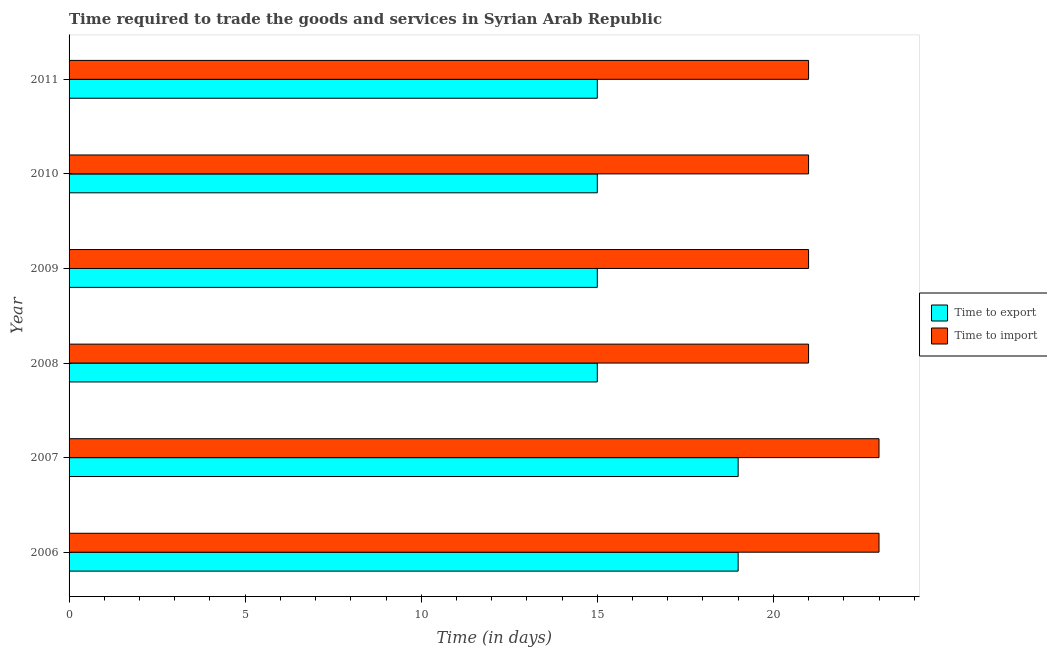How many groups of bars are there?
Make the answer very short. 6. Are the number of bars per tick equal to the number of legend labels?
Keep it short and to the point. Yes. Are the number of bars on each tick of the Y-axis equal?
Provide a succinct answer. Yes. How many bars are there on the 5th tick from the top?
Offer a very short reply. 2. How many bars are there on the 2nd tick from the bottom?
Keep it short and to the point. 2. In how many cases, is the number of bars for a given year not equal to the number of legend labels?
Provide a succinct answer. 0. What is the time to export in 2006?
Your answer should be compact. 19. Across all years, what is the maximum time to export?
Make the answer very short. 19. Across all years, what is the minimum time to export?
Provide a succinct answer. 15. What is the total time to import in the graph?
Offer a terse response. 130. What is the difference between the time to import in 2006 and that in 2010?
Offer a very short reply. 2. What is the difference between the time to export in 2008 and the time to import in 2009?
Your response must be concise. -6. What is the average time to import per year?
Offer a terse response. 21.67. In how many years, is the time to export greater than 6 days?
Provide a short and direct response. 6. Is the time to export in 2006 less than that in 2010?
Ensure brevity in your answer.  No. Is the difference between the time to import in 2006 and 2011 greater than the difference between the time to export in 2006 and 2011?
Give a very brief answer. No. What is the difference between the highest and the lowest time to import?
Keep it short and to the point. 2. Is the sum of the time to export in 2006 and 2010 greater than the maximum time to import across all years?
Provide a short and direct response. Yes. What does the 2nd bar from the top in 2011 represents?
Make the answer very short. Time to export. What does the 2nd bar from the bottom in 2011 represents?
Offer a very short reply. Time to import. How many bars are there?
Your answer should be very brief. 12. Does the graph contain any zero values?
Provide a succinct answer. No. Where does the legend appear in the graph?
Make the answer very short. Center right. How many legend labels are there?
Your answer should be compact. 2. What is the title of the graph?
Provide a short and direct response. Time required to trade the goods and services in Syrian Arab Republic. What is the label or title of the X-axis?
Offer a very short reply. Time (in days). What is the label or title of the Y-axis?
Make the answer very short. Year. What is the Time (in days) in Time to export in 2006?
Your answer should be very brief. 19. What is the Time (in days) of Time to import in 2006?
Ensure brevity in your answer.  23. What is the Time (in days) of Time to import in 2007?
Provide a short and direct response. 23. What is the Time (in days) in Time to export in 2008?
Make the answer very short. 15. What is the Time (in days) of Time to export in 2009?
Make the answer very short. 15. What is the Time (in days) in Time to export in 2010?
Give a very brief answer. 15. What is the Time (in days) of Time to import in 2010?
Make the answer very short. 21. What is the Time (in days) in Time to export in 2011?
Make the answer very short. 15. Across all years, what is the minimum Time (in days) in Time to export?
Offer a terse response. 15. What is the total Time (in days) of Time to export in the graph?
Your answer should be very brief. 98. What is the total Time (in days) of Time to import in the graph?
Offer a terse response. 130. What is the difference between the Time (in days) in Time to import in 2006 and that in 2008?
Your answer should be very brief. 2. What is the difference between the Time (in days) in Time to import in 2006 and that in 2009?
Provide a succinct answer. 2. What is the difference between the Time (in days) of Time to export in 2006 and that in 2011?
Provide a succinct answer. 4. What is the difference between the Time (in days) of Time to export in 2007 and that in 2008?
Offer a very short reply. 4. What is the difference between the Time (in days) in Time to export in 2007 and that in 2011?
Make the answer very short. 4. What is the difference between the Time (in days) of Time to export in 2008 and that in 2009?
Your answer should be very brief. 0. What is the difference between the Time (in days) in Time to import in 2008 and that in 2009?
Give a very brief answer. 0. What is the difference between the Time (in days) of Time to import in 2008 and that in 2010?
Offer a terse response. 0. What is the difference between the Time (in days) in Time to export in 2008 and that in 2011?
Make the answer very short. 0. What is the difference between the Time (in days) in Time to import in 2009 and that in 2010?
Ensure brevity in your answer.  0. What is the difference between the Time (in days) in Time to import in 2009 and that in 2011?
Provide a short and direct response. 0. What is the difference between the Time (in days) in Time to import in 2010 and that in 2011?
Keep it short and to the point. 0. What is the difference between the Time (in days) in Time to export in 2006 and the Time (in days) in Time to import in 2009?
Your answer should be compact. -2. What is the difference between the Time (in days) of Time to export in 2006 and the Time (in days) of Time to import in 2011?
Provide a short and direct response. -2. What is the difference between the Time (in days) of Time to export in 2007 and the Time (in days) of Time to import in 2008?
Offer a terse response. -2. What is the difference between the Time (in days) of Time to export in 2007 and the Time (in days) of Time to import in 2009?
Provide a short and direct response. -2. What is the difference between the Time (in days) in Time to export in 2007 and the Time (in days) in Time to import in 2010?
Your answer should be very brief. -2. What is the difference between the Time (in days) in Time to export in 2007 and the Time (in days) in Time to import in 2011?
Offer a very short reply. -2. What is the difference between the Time (in days) of Time to export in 2008 and the Time (in days) of Time to import in 2009?
Your response must be concise. -6. What is the difference between the Time (in days) of Time to export in 2008 and the Time (in days) of Time to import in 2011?
Offer a very short reply. -6. What is the average Time (in days) of Time to export per year?
Your answer should be very brief. 16.33. What is the average Time (in days) in Time to import per year?
Provide a short and direct response. 21.67. In the year 2006, what is the difference between the Time (in days) of Time to export and Time (in days) of Time to import?
Give a very brief answer. -4. In the year 2008, what is the difference between the Time (in days) in Time to export and Time (in days) in Time to import?
Provide a short and direct response. -6. In the year 2009, what is the difference between the Time (in days) in Time to export and Time (in days) in Time to import?
Make the answer very short. -6. In the year 2010, what is the difference between the Time (in days) in Time to export and Time (in days) in Time to import?
Provide a succinct answer. -6. In the year 2011, what is the difference between the Time (in days) of Time to export and Time (in days) of Time to import?
Provide a succinct answer. -6. What is the ratio of the Time (in days) in Time to export in 2006 to that in 2008?
Your answer should be compact. 1.27. What is the ratio of the Time (in days) of Time to import in 2006 to that in 2008?
Keep it short and to the point. 1.1. What is the ratio of the Time (in days) in Time to export in 2006 to that in 2009?
Ensure brevity in your answer.  1.27. What is the ratio of the Time (in days) in Time to import in 2006 to that in 2009?
Offer a terse response. 1.1. What is the ratio of the Time (in days) in Time to export in 2006 to that in 2010?
Offer a terse response. 1.27. What is the ratio of the Time (in days) in Time to import in 2006 to that in 2010?
Provide a succinct answer. 1.1. What is the ratio of the Time (in days) in Time to export in 2006 to that in 2011?
Offer a terse response. 1.27. What is the ratio of the Time (in days) in Time to import in 2006 to that in 2011?
Your answer should be compact. 1.1. What is the ratio of the Time (in days) of Time to export in 2007 to that in 2008?
Ensure brevity in your answer.  1.27. What is the ratio of the Time (in days) in Time to import in 2007 to that in 2008?
Make the answer very short. 1.1. What is the ratio of the Time (in days) in Time to export in 2007 to that in 2009?
Make the answer very short. 1.27. What is the ratio of the Time (in days) in Time to import in 2007 to that in 2009?
Provide a short and direct response. 1.1. What is the ratio of the Time (in days) in Time to export in 2007 to that in 2010?
Offer a terse response. 1.27. What is the ratio of the Time (in days) in Time to import in 2007 to that in 2010?
Your response must be concise. 1.1. What is the ratio of the Time (in days) of Time to export in 2007 to that in 2011?
Your answer should be compact. 1.27. What is the ratio of the Time (in days) in Time to import in 2007 to that in 2011?
Your answer should be compact. 1.1. What is the ratio of the Time (in days) of Time to import in 2008 to that in 2009?
Your answer should be compact. 1. What is the ratio of the Time (in days) of Time to export in 2008 to that in 2011?
Ensure brevity in your answer.  1. What is the ratio of the Time (in days) of Time to import in 2008 to that in 2011?
Keep it short and to the point. 1. What is the ratio of the Time (in days) in Time to export in 2009 to that in 2010?
Your answer should be compact. 1. What is the ratio of the Time (in days) in Time to import in 2009 to that in 2010?
Offer a terse response. 1. What is the difference between the highest and the second highest Time (in days) of Time to export?
Give a very brief answer. 0. What is the difference between the highest and the second highest Time (in days) of Time to import?
Make the answer very short. 0. What is the difference between the highest and the lowest Time (in days) of Time to export?
Keep it short and to the point. 4. What is the difference between the highest and the lowest Time (in days) of Time to import?
Keep it short and to the point. 2. 